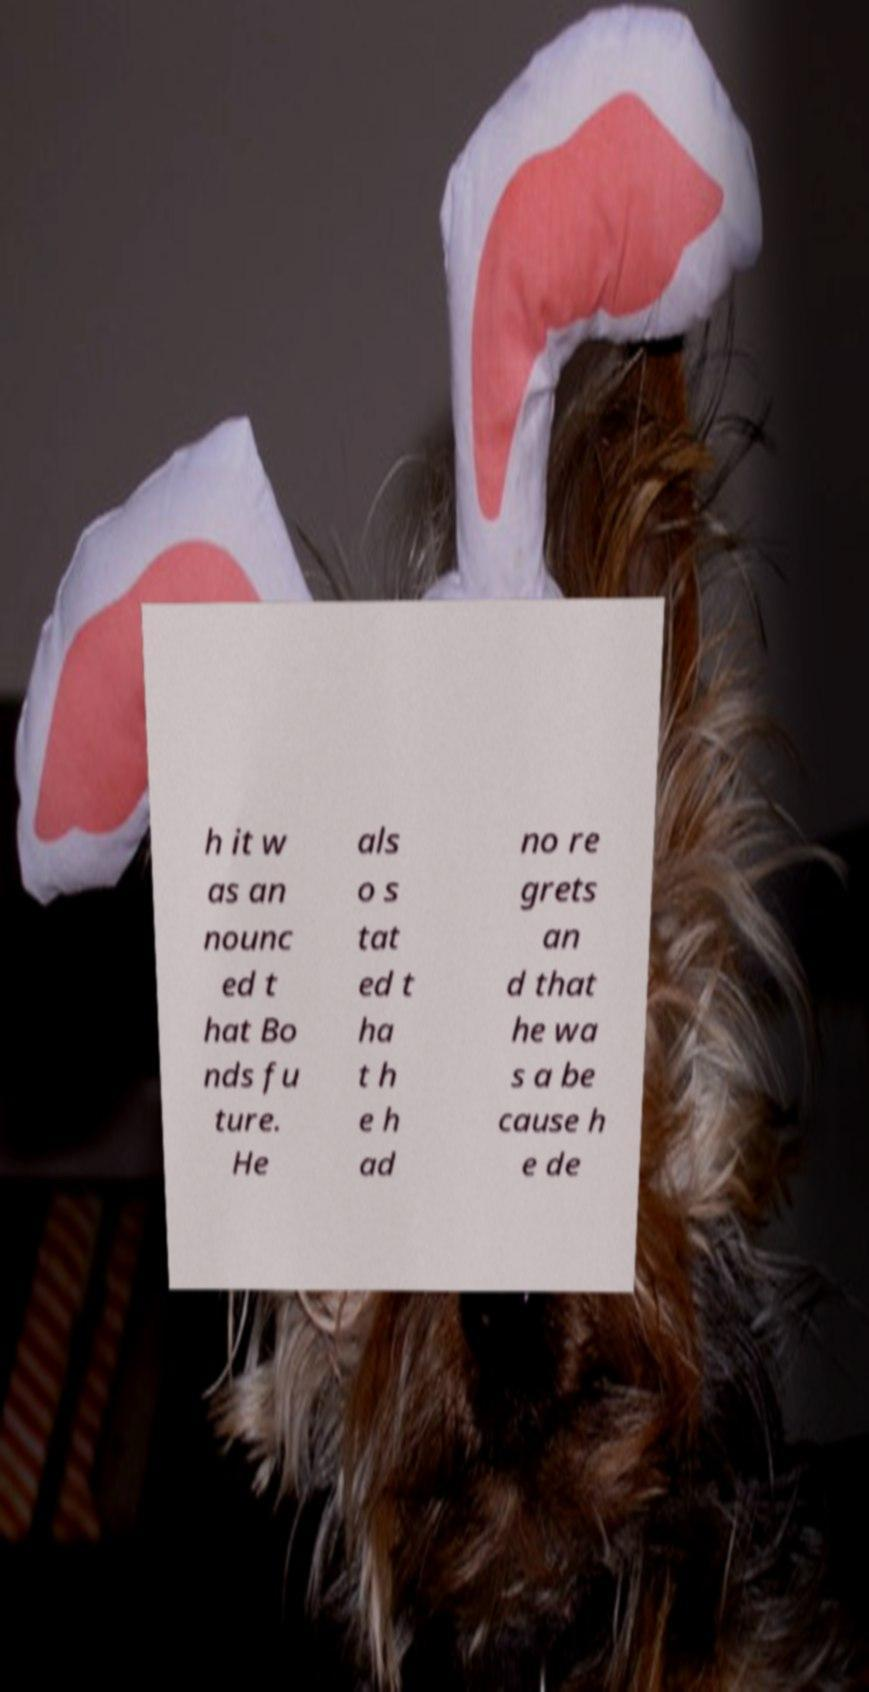Can you accurately transcribe the text from the provided image for me? h it w as an nounc ed t hat Bo nds fu ture. He als o s tat ed t ha t h e h ad no re grets an d that he wa s a be cause h e de 